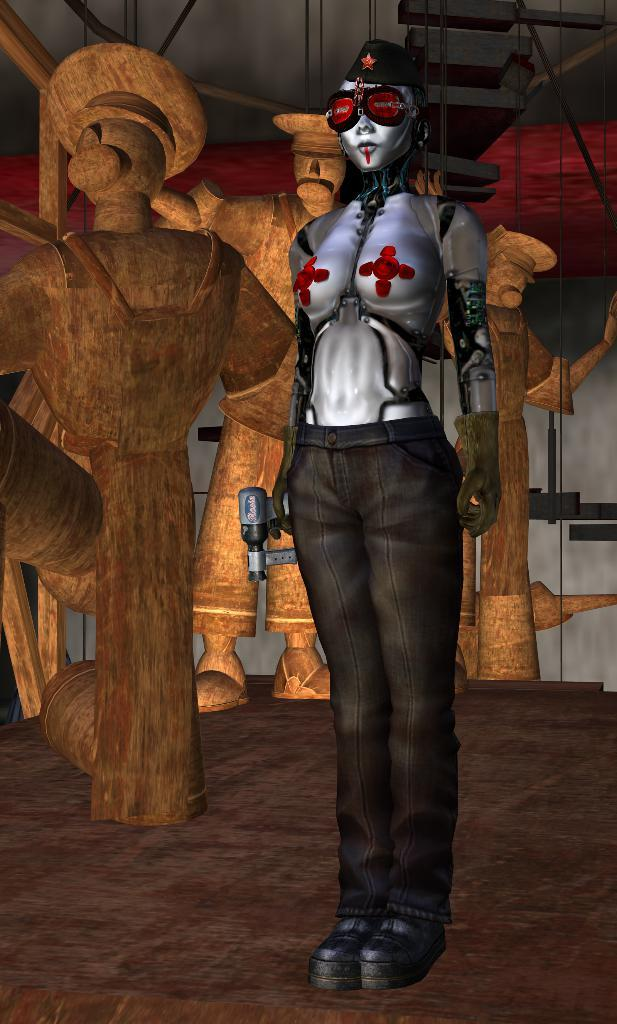What type of environment is depicted in the image? The image shows a garden. What features can be found in the garden? There are flowers and a fountain in the garden. Are there any seating options in the garden? Yes, there are benches in the garden. What type of boot is being worn by the flowers in the garden? There are no boots present in the image, as the image features a garden with flowers and a fountain. 